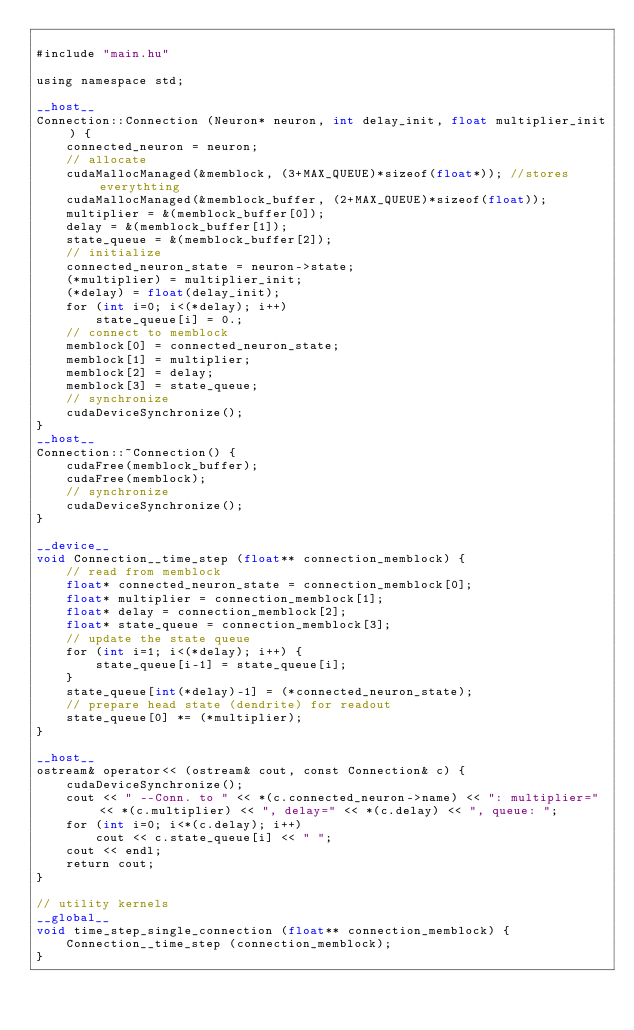<code> <loc_0><loc_0><loc_500><loc_500><_Cuda_>
#include "main.hu"

using namespace std;

__host__
Connection::Connection (Neuron* neuron, int delay_init, float multiplier_init) {
    connected_neuron = neuron;
    // allocate
    cudaMallocManaged(&memblock, (3+MAX_QUEUE)*sizeof(float*)); //stores everythting
    cudaMallocManaged(&memblock_buffer, (2+MAX_QUEUE)*sizeof(float));
    multiplier = &(memblock_buffer[0]);
    delay = &(memblock_buffer[1]);
    state_queue = &(memblock_buffer[2]);
    // initialize
    connected_neuron_state = neuron->state;
    (*multiplier) = multiplier_init;
    (*delay) = float(delay_init);
    for (int i=0; i<(*delay); i++)
        state_queue[i] = 0.;
    // connect to memblock
    memblock[0] = connected_neuron_state;
    memblock[1] = multiplier;
    memblock[2] = delay;
    memblock[3] = state_queue;
    // synchronize
    cudaDeviceSynchronize();
}
__host__
Connection::~Connection() {
    cudaFree(memblock_buffer);
    cudaFree(memblock);
    // synchronize
    cudaDeviceSynchronize();
}

__device__
void Connection__time_step (float** connection_memblock) {
    // read from memblock
    float* connected_neuron_state = connection_memblock[0];
    float* multiplier = connection_memblock[1];
    float* delay = connection_memblock[2];
    float* state_queue = connection_memblock[3];
    // update the state queue
    for (int i=1; i<(*delay); i++) {
        state_queue[i-1] = state_queue[i];
    }
    state_queue[int(*delay)-1] = (*connected_neuron_state);
    // prepare head state (dendrite) for readout
    state_queue[0] *= (*multiplier);
}

__host__
ostream& operator<< (ostream& cout, const Connection& c) {
    cudaDeviceSynchronize();
    cout << " --Conn. to " << *(c.connected_neuron->name) << ": multiplier=" << *(c.multiplier) << ", delay=" << *(c.delay) << ", queue: ";
    for (int i=0; i<*(c.delay); i++)
        cout << c.state_queue[i] << " ";
    cout << endl;
    return cout;
}

// utility kernels
__global__
void time_step_single_connection (float** connection_memblock) {
    Connection__time_step (connection_memblock);
}</code> 